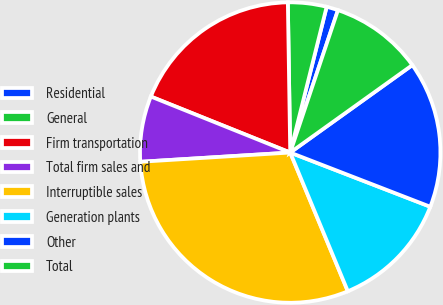<chart> <loc_0><loc_0><loc_500><loc_500><pie_chart><fcel>Residential<fcel>General<fcel>Firm transportation<fcel>Total firm sales and<fcel>Interruptible sales<fcel>Generation plants<fcel>Other<fcel>Total<nl><fcel>1.25%<fcel>4.15%<fcel>18.67%<fcel>7.06%<fcel>30.29%<fcel>12.86%<fcel>15.77%<fcel>9.96%<nl></chart> 